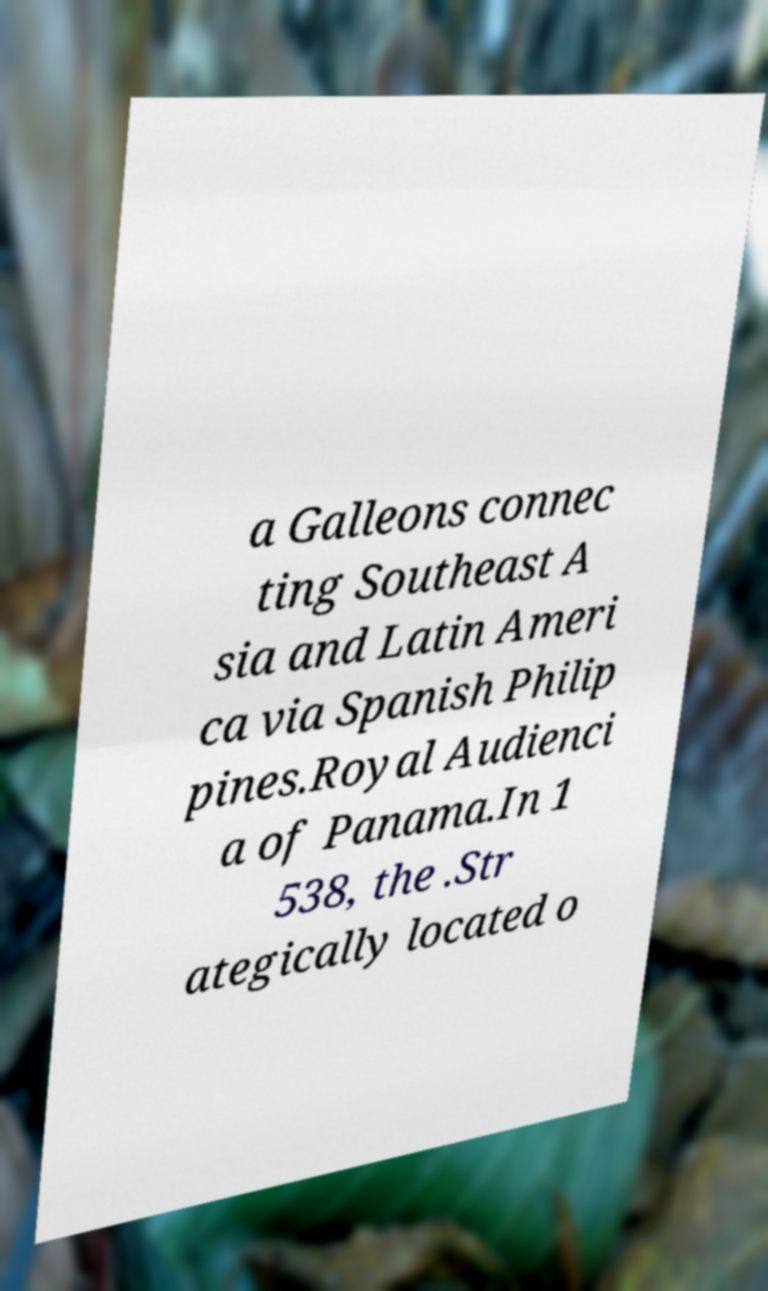Please identify and transcribe the text found in this image. a Galleons connec ting Southeast A sia and Latin Ameri ca via Spanish Philip pines.Royal Audienci a of Panama.In 1 538, the .Str ategically located o 